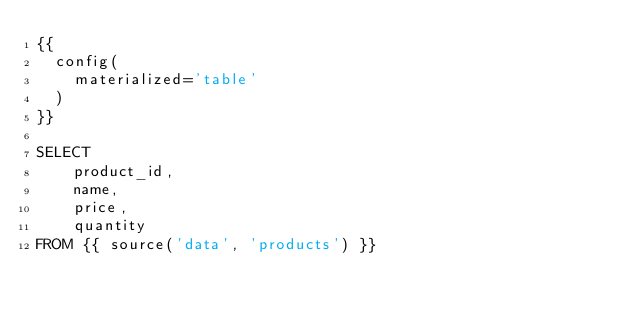Convert code to text. <code><loc_0><loc_0><loc_500><loc_500><_SQL_>{{
  config(
    materialized='table'
  )
}}

SELECT 
    product_id,
    name,
    price,
    quantity
FROM {{ source('data', 'products') }}</code> 